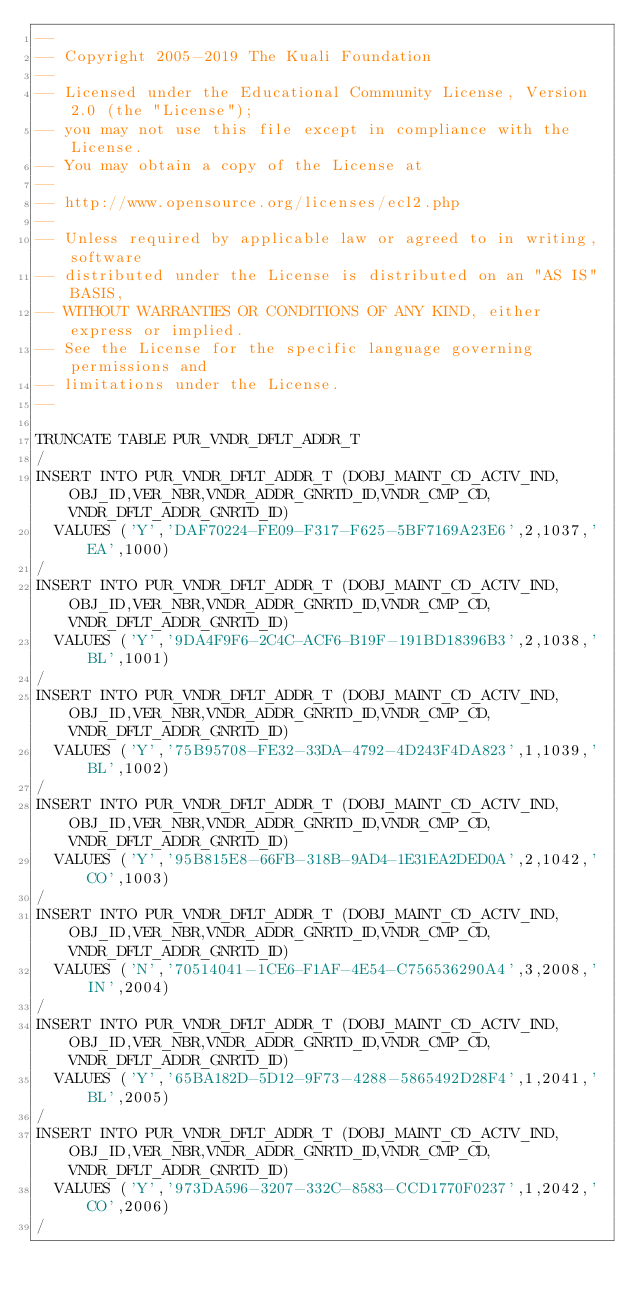Convert code to text. <code><loc_0><loc_0><loc_500><loc_500><_SQL_>--
-- Copyright 2005-2019 The Kuali Foundation
--
-- Licensed under the Educational Community License, Version 2.0 (the "License");
-- you may not use this file except in compliance with the License.
-- You may obtain a copy of the License at
--
-- http://www.opensource.org/licenses/ecl2.php
--
-- Unless required by applicable law or agreed to in writing, software
-- distributed under the License is distributed on an "AS IS" BASIS,
-- WITHOUT WARRANTIES OR CONDITIONS OF ANY KIND, either express or implied.
-- See the License for the specific language governing permissions and
-- limitations under the License.
--

TRUNCATE TABLE PUR_VNDR_DFLT_ADDR_T
/
INSERT INTO PUR_VNDR_DFLT_ADDR_T (DOBJ_MAINT_CD_ACTV_IND,OBJ_ID,VER_NBR,VNDR_ADDR_GNRTD_ID,VNDR_CMP_CD,VNDR_DFLT_ADDR_GNRTD_ID)
  VALUES ('Y','DAF70224-FE09-F317-F625-5BF7169A23E6',2,1037,'EA',1000)
/
INSERT INTO PUR_VNDR_DFLT_ADDR_T (DOBJ_MAINT_CD_ACTV_IND,OBJ_ID,VER_NBR,VNDR_ADDR_GNRTD_ID,VNDR_CMP_CD,VNDR_DFLT_ADDR_GNRTD_ID)
  VALUES ('Y','9DA4F9F6-2C4C-ACF6-B19F-191BD18396B3',2,1038,'BL',1001)
/
INSERT INTO PUR_VNDR_DFLT_ADDR_T (DOBJ_MAINT_CD_ACTV_IND,OBJ_ID,VER_NBR,VNDR_ADDR_GNRTD_ID,VNDR_CMP_CD,VNDR_DFLT_ADDR_GNRTD_ID)
  VALUES ('Y','75B95708-FE32-33DA-4792-4D243F4DA823',1,1039,'BL',1002)
/
INSERT INTO PUR_VNDR_DFLT_ADDR_T (DOBJ_MAINT_CD_ACTV_IND,OBJ_ID,VER_NBR,VNDR_ADDR_GNRTD_ID,VNDR_CMP_CD,VNDR_DFLT_ADDR_GNRTD_ID)
  VALUES ('Y','95B815E8-66FB-318B-9AD4-1E31EA2DED0A',2,1042,'CO',1003)
/
INSERT INTO PUR_VNDR_DFLT_ADDR_T (DOBJ_MAINT_CD_ACTV_IND,OBJ_ID,VER_NBR,VNDR_ADDR_GNRTD_ID,VNDR_CMP_CD,VNDR_DFLT_ADDR_GNRTD_ID)
  VALUES ('N','70514041-1CE6-F1AF-4E54-C756536290A4',3,2008,'IN',2004)
/
INSERT INTO PUR_VNDR_DFLT_ADDR_T (DOBJ_MAINT_CD_ACTV_IND,OBJ_ID,VER_NBR,VNDR_ADDR_GNRTD_ID,VNDR_CMP_CD,VNDR_DFLT_ADDR_GNRTD_ID)
  VALUES ('Y','65BA182D-5D12-9F73-4288-5865492D28F4',1,2041,'BL',2005)
/
INSERT INTO PUR_VNDR_DFLT_ADDR_T (DOBJ_MAINT_CD_ACTV_IND,OBJ_ID,VER_NBR,VNDR_ADDR_GNRTD_ID,VNDR_CMP_CD,VNDR_DFLT_ADDR_GNRTD_ID)
  VALUES ('Y','973DA596-3207-332C-8583-CCD1770F0237',1,2042,'CO',2006)
/
</code> 